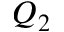Convert formula to latex. <formula><loc_0><loc_0><loc_500><loc_500>Q _ { 2 }</formula> 